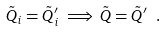<formula> <loc_0><loc_0><loc_500><loc_500>\tilde { Q } _ { i } = \tilde { Q } _ { i } ^ { \prime } \implies \tilde { Q } = \tilde { Q } ^ { \prime } \ .</formula> 